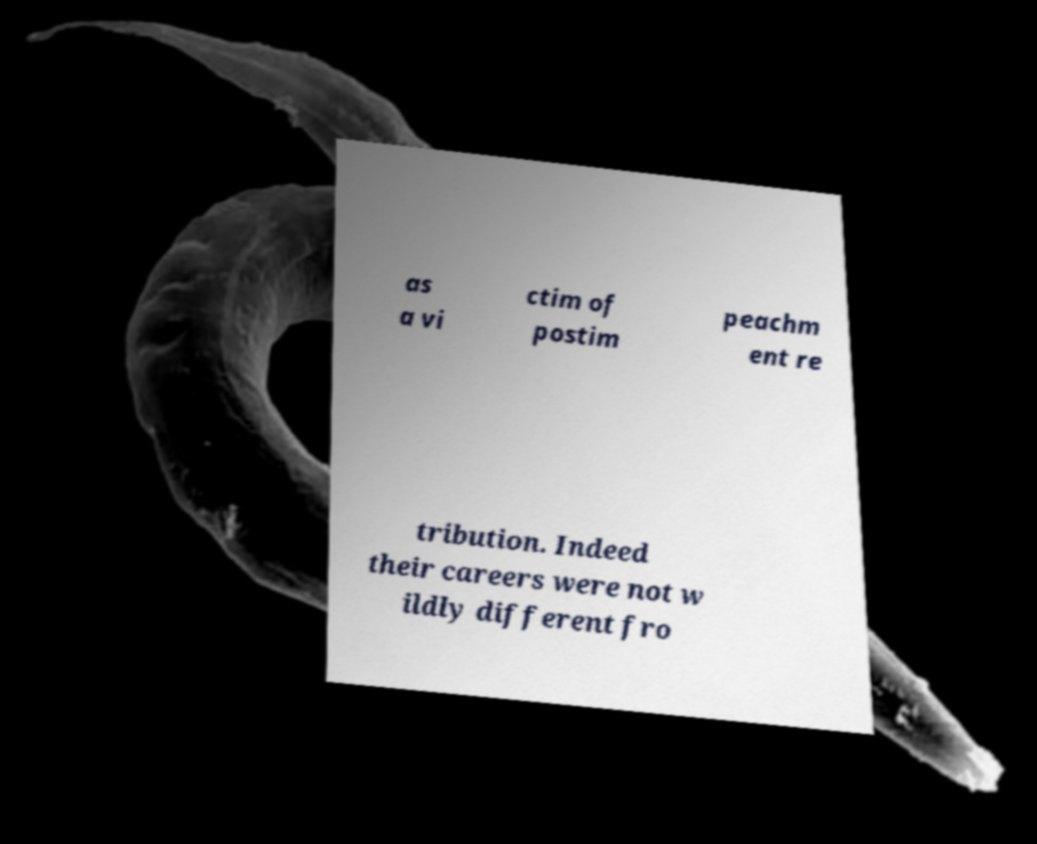What messages or text are displayed in this image? I need them in a readable, typed format. as a vi ctim of postim peachm ent re tribution. Indeed their careers were not w ildly different fro 